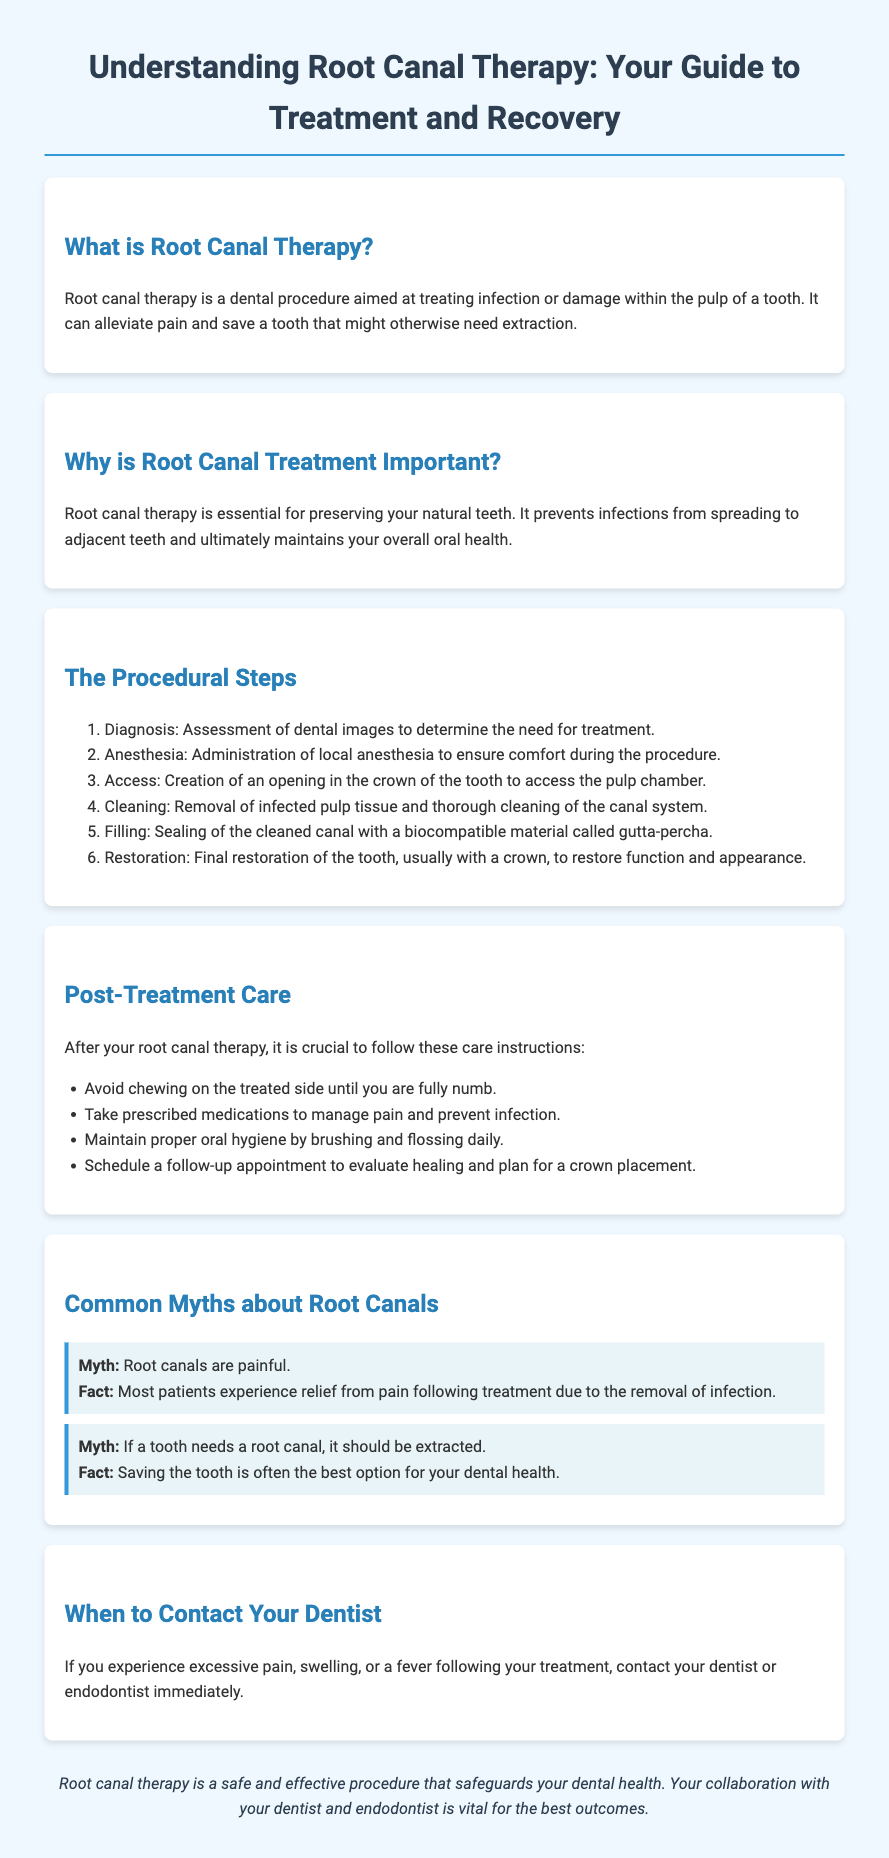What is root canal therapy? Root canal therapy is defined in the document as a dental procedure aimed at treating infection or damage within the pulp of a tooth.
Answer: A dental procedure aimed at treating infection or damage within the pulp of a tooth What is the first step in the procedural steps? The procedural steps outline the sequence of actions taken during root canal therapy, starting with the diagnosis.
Answer: Diagnosis What material is used to fill the cleaned canal? The document specifies the biocompatible material used during the filling step of the procedure.
Answer: Gutta-percha What should you avoid after root canal therapy? Post-treatment care instructions include specific activities to avoid to ensure proper healing.
Answer: Chewing on the treated side What is a common myth about root canals? The document lists misconceptions about root canal therapy, highlighting two specific myths and their corresponding facts.
Answer: Root canals are painful What should you do if you experience excessive pain after treatment? The document advises on actions to take in case of specific symptoms following the treatment.
Answer: Contact your dentist or endodontist immediately Why is root canal treatment important? The document explains the significance of root canal therapy, focusing on its impact on dental health and preservation of natural teeth.
Answer: Preserving your natural teeth What type of document is this? The overall content and intent of the document are to educate patients about a dental procedure and its aftermath.
Answer: Patient education brochure 